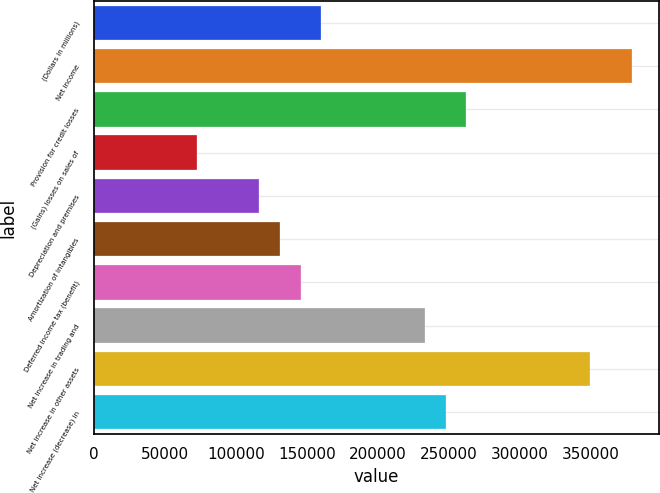Convert chart. <chart><loc_0><loc_0><loc_500><loc_500><bar_chart><fcel>(Dollars in millions)<fcel>Net income<fcel>Provision for credit losses<fcel>(Gains) losses on sales of<fcel>Depreciation and premises<fcel>Amortization of intangibles<fcel>Deferred income tax (benefit)<fcel>Net increase in trading and<fcel>Net increase in other assets<fcel>Net increase (decrease) in<nl><fcel>160356<fcel>379014<fcel>262397<fcel>72893<fcel>116625<fcel>131202<fcel>145779<fcel>233242<fcel>349860<fcel>247819<nl></chart> 